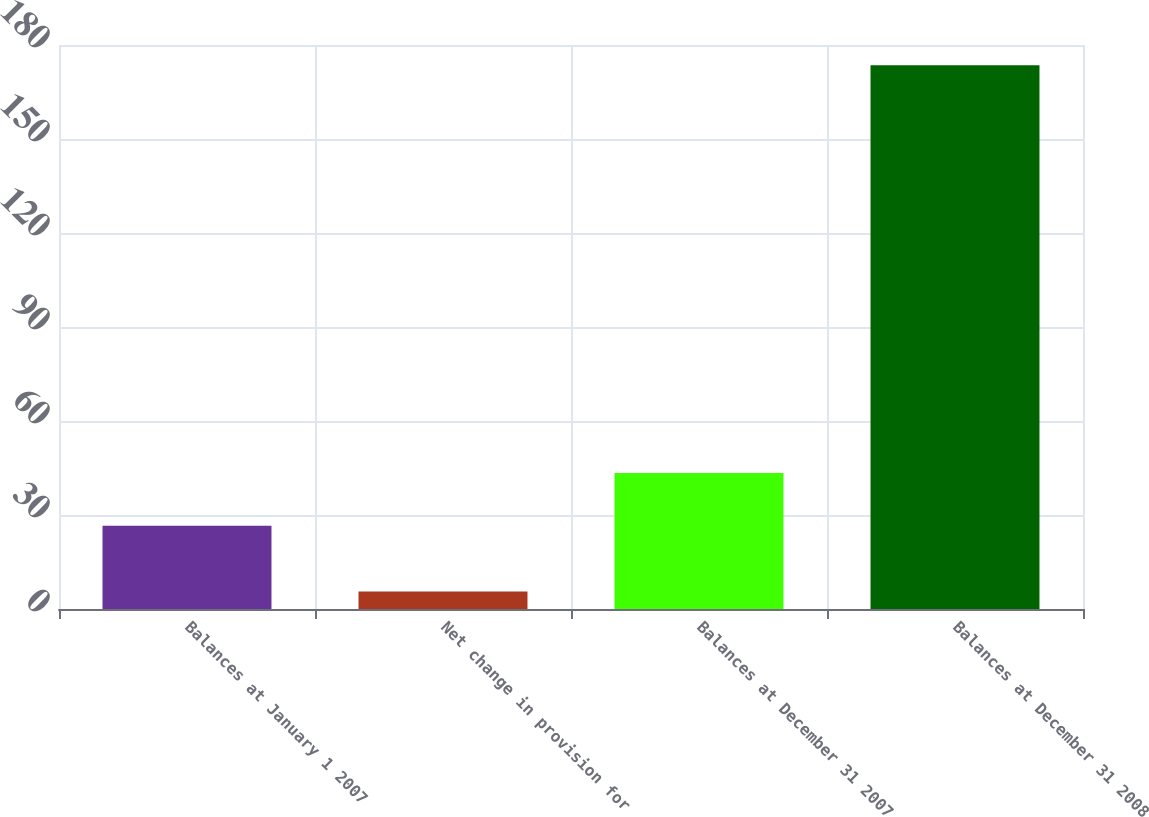Convert chart. <chart><loc_0><loc_0><loc_500><loc_500><bar_chart><fcel>Balances at January 1 2007<fcel>Net change in provision for<fcel>Balances at December 31 2007<fcel>Balances at December 31 2008<nl><fcel>26.6<fcel>5.6<fcel>43.39<fcel>173.5<nl></chart> 